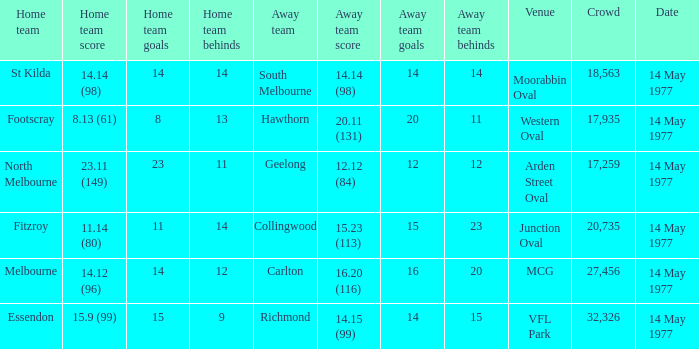I want to know the home team score of the away team of richmond that has a crowd more than 20,735 15.9 (99). 